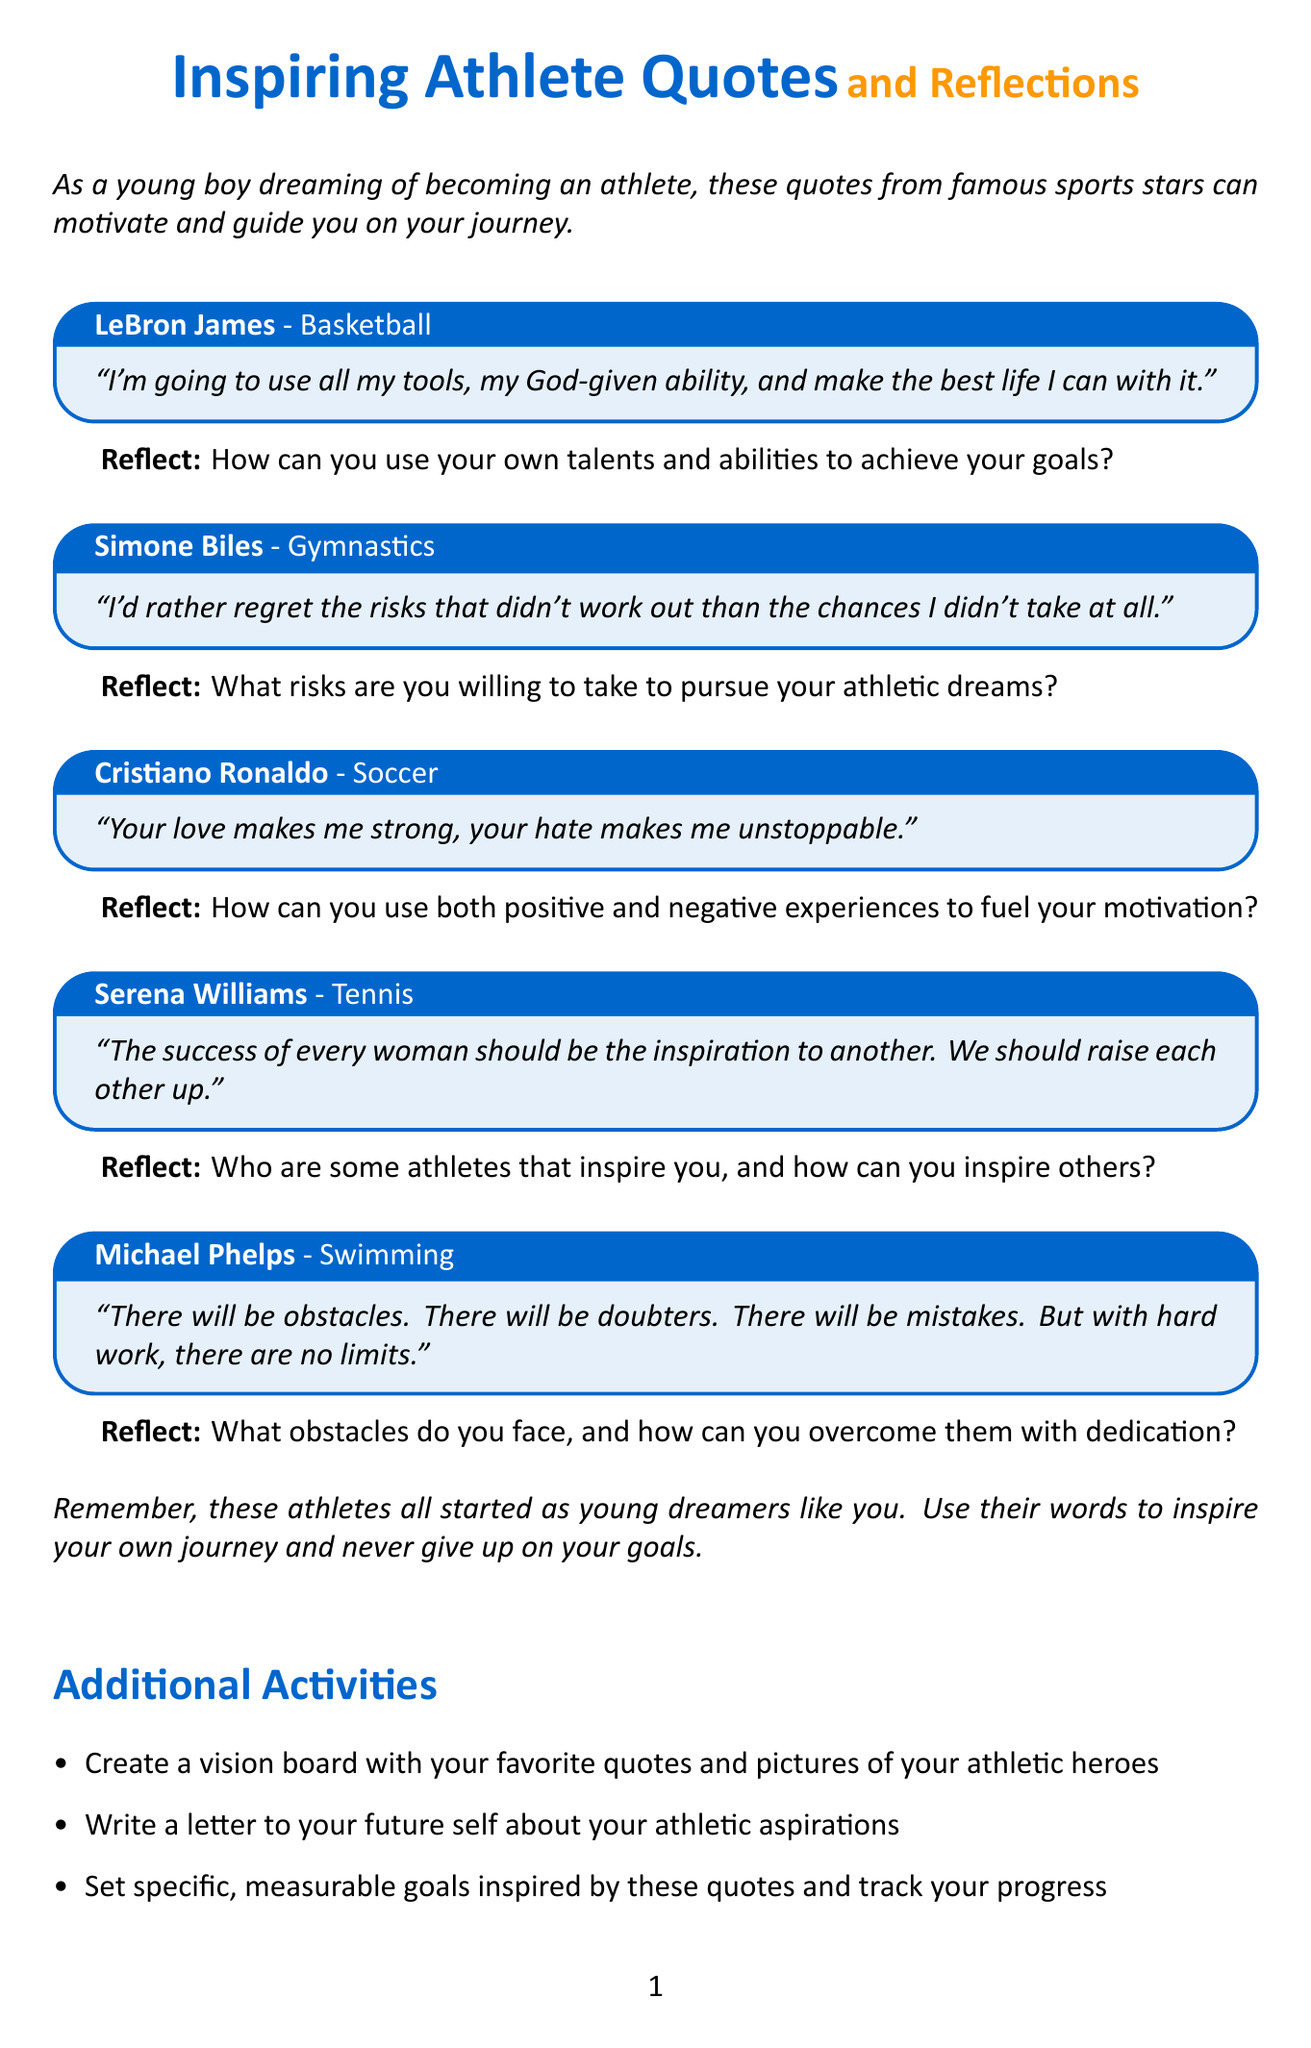What is the title of the document? The title appears at the top of the document and is clearly stated as "Inspiring Athlete Quotes and Reflections."
Answer: Inspiring Athlete Quotes and Reflections Who is the first athlete quoted in the document? The first athlete mentioned in the quotes section is LeBron James.
Answer: LeBron James How many quotes are included in the document? The document lists five quotes from different athletes.
Answer: 5 What sport does Simone Biles participate in? The document specifies that Simone Biles is a gymnast, under the sport category of Gymnastics.
Answer: Gymnastics What is the focus of the additional activities section? The additional activities suggest practical steps to engage with the quotes and reflect on personal aspirations.
Answer: Engagement with quotes What can you create according to the additional activities section? The additional activities suggest creating a vision board.
Answer: Vision board How does Michael Phelps describe the impact of obstacles and mistakes? Michael Phelps mentions that obstacles and mistakes can be overcome with hard work, indicating that they have no limits.
Answer: No limits What type of reflection prompt follows Cristiano Ronaldo's quote? The reflection prompt asks about utilizing both positive and negative experiences for motivation.
Answer: Fuel your motivation 